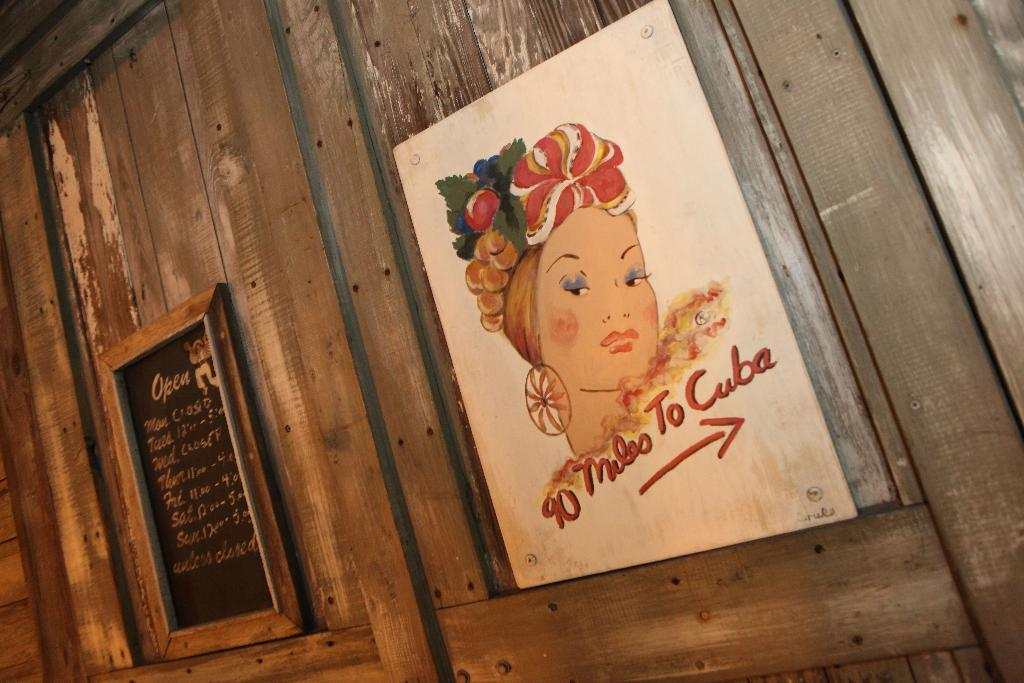<image>
Provide a brief description of the given image. a plaque on a wall that says '90 miles to cuba' 